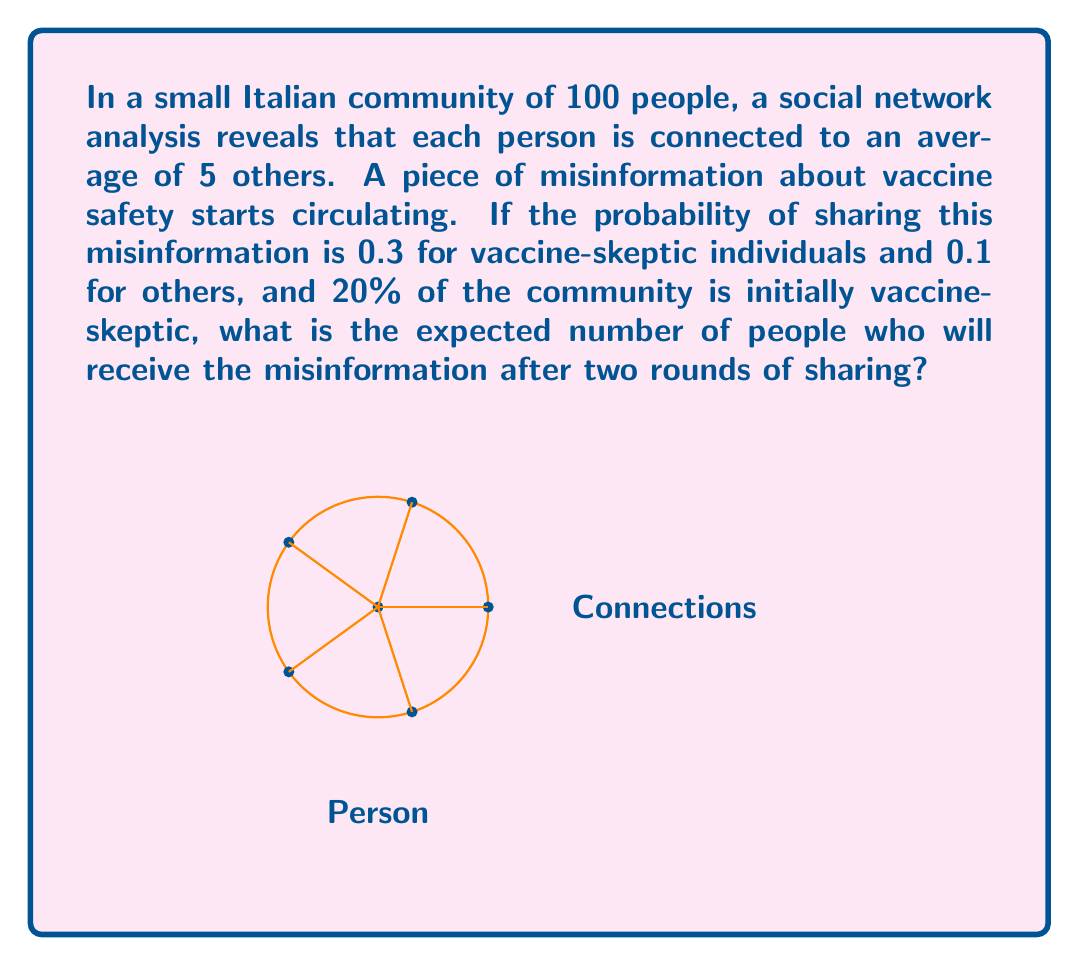Solve this math problem. Let's approach this step-by-step:

1) First, let's calculate the number of vaccine-skeptic individuals:
   $20\% \text{ of } 100 = 20$ vaccine-skeptic individuals

2) In the first round:
   - Each person is connected to an average of 5 others.
   - Probability of sharing for skeptics: 0.3
   - Probability of sharing for others: 0.1
   
   Expected number of people sharing in first round:
   $$(20 \times 0.3) + (80 \times 0.1) = 6 + 8 = 14$$

3) Each of these 14 people will share with 5 others on average. However, some of these might overlap, so we need to calculate the probability of a person not receiving the misinformation.

4) Probability of not receiving from one sharer:
   $$1 - \frac{5}{99} \approx 0.9495$$
   (We use 99 instead of 100 because a person can't share with themselves)

5) Probability of not receiving from any of the 14 sharers:
   $$(0.9495)^{14} \approx 0.4845$$

6) Therefore, the probability of receiving the misinformation:
   $$1 - 0.4845 = 0.5155$$

7) Expected number of people receiving the misinformation after two rounds:
   $$100 \times 0.5155 = 51.55$$
Answer: 51.55 people 